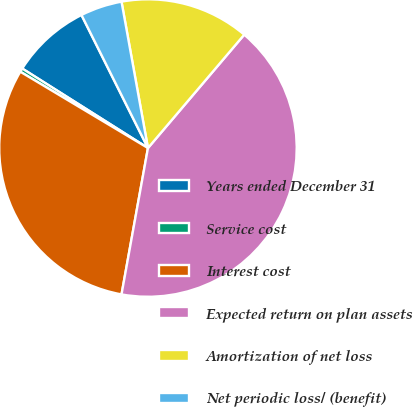<chart> <loc_0><loc_0><loc_500><loc_500><pie_chart><fcel>Years ended December 31<fcel>Service cost<fcel>Interest cost<fcel>Expected return on plan assets<fcel>Amortization of net loss<fcel>Net periodic loss/ (benefit)<nl><fcel>8.65%<fcel>0.4%<fcel>30.73%<fcel>41.64%<fcel>14.05%<fcel>4.53%<nl></chart> 